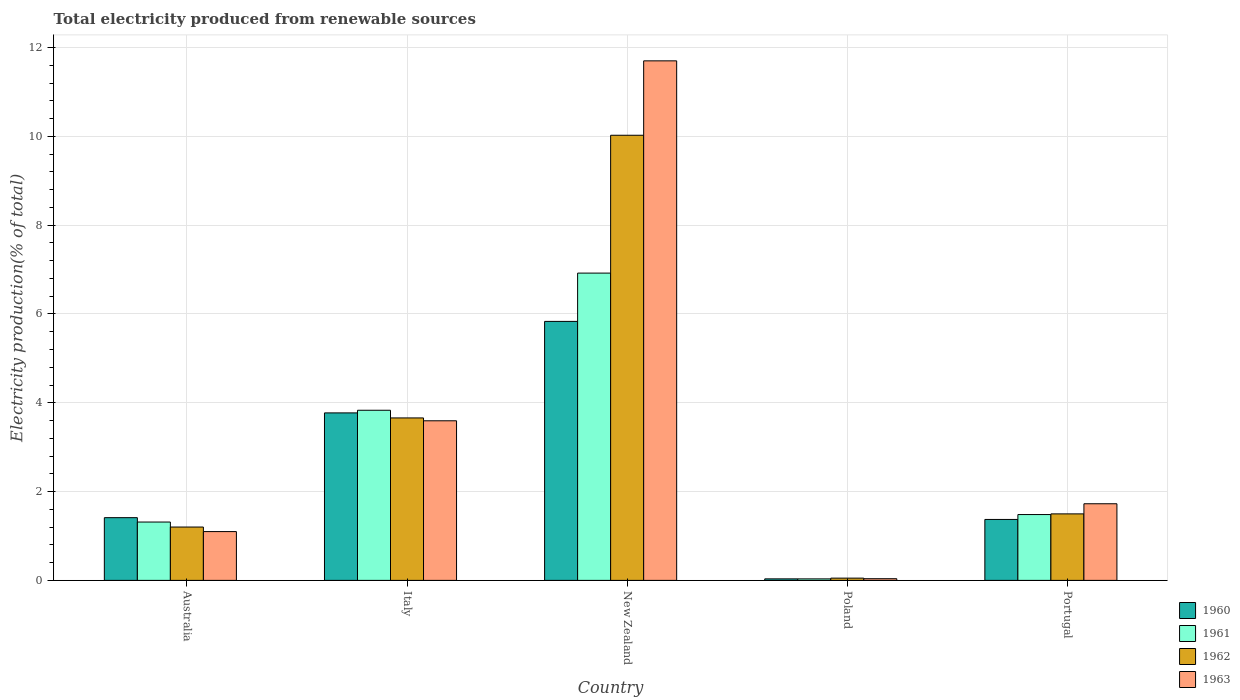Are the number of bars per tick equal to the number of legend labels?
Your answer should be very brief. Yes. Are the number of bars on each tick of the X-axis equal?
Your response must be concise. Yes. What is the label of the 1st group of bars from the left?
Ensure brevity in your answer.  Australia. In how many cases, is the number of bars for a given country not equal to the number of legend labels?
Make the answer very short. 0. What is the total electricity produced in 1962 in Australia?
Offer a terse response. 1.2. Across all countries, what is the maximum total electricity produced in 1962?
Keep it short and to the point. 10.02. Across all countries, what is the minimum total electricity produced in 1962?
Offer a terse response. 0.05. In which country was the total electricity produced in 1962 maximum?
Offer a very short reply. New Zealand. What is the total total electricity produced in 1962 in the graph?
Your answer should be very brief. 16.43. What is the difference between the total electricity produced in 1963 in New Zealand and that in Portugal?
Offer a terse response. 9.97. What is the difference between the total electricity produced in 1962 in Italy and the total electricity produced in 1960 in Australia?
Provide a succinct answer. 2.25. What is the average total electricity produced in 1962 per country?
Offer a terse response. 3.29. What is the difference between the total electricity produced of/in 1962 and total electricity produced of/in 1961 in Australia?
Provide a short and direct response. -0.11. What is the ratio of the total electricity produced in 1962 in Australia to that in Italy?
Provide a short and direct response. 0.33. Is the total electricity produced in 1962 in Australia less than that in Italy?
Offer a very short reply. Yes. What is the difference between the highest and the second highest total electricity produced in 1963?
Keep it short and to the point. 1.87. What is the difference between the highest and the lowest total electricity produced in 1963?
Your answer should be compact. 11.66. Is the sum of the total electricity produced in 1960 in Italy and New Zealand greater than the maximum total electricity produced in 1962 across all countries?
Provide a short and direct response. No. Is it the case that in every country, the sum of the total electricity produced in 1963 and total electricity produced in 1960 is greater than the sum of total electricity produced in 1961 and total electricity produced in 1962?
Make the answer very short. No. What does the 3rd bar from the left in Italy represents?
Offer a very short reply. 1962. Is it the case that in every country, the sum of the total electricity produced in 1960 and total electricity produced in 1961 is greater than the total electricity produced in 1963?
Keep it short and to the point. Yes. Are all the bars in the graph horizontal?
Offer a terse response. No. How many countries are there in the graph?
Provide a succinct answer. 5. What is the difference between two consecutive major ticks on the Y-axis?
Make the answer very short. 2. Are the values on the major ticks of Y-axis written in scientific E-notation?
Your response must be concise. No. Does the graph contain any zero values?
Offer a very short reply. No. Does the graph contain grids?
Your response must be concise. Yes. What is the title of the graph?
Ensure brevity in your answer.  Total electricity produced from renewable sources. Does "1991" appear as one of the legend labels in the graph?
Give a very brief answer. No. What is the label or title of the Y-axis?
Provide a succinct answer. Electricity production(% of total). What is the Electricity production(% of total) of 1960 in Australia?
Your response must be concise. 1.41. What is the Electricity production(% of total) in 1961 in Australia?
Make the answer very short. 1.31. What is the Electricity production(% of total) of 1962 in Australia?
Keep it short and to the point. 1.2. What is the Electricity production(% of total) of 1963 in Australia?
Provide a succinct answer. 1.1. What is the Electricity production(% of total) in 1960 in Italy?
Provide a short and direct response. 3.77. What is the Electricity production(% of total) of 1961 in Italy?
Ensure brevity in your answer.  3.83. What is the Electricity production(% of total) in 1962 in Italy?
Your response must be concise. 3.66. What is the Electricity production(% of total) of 1963 in Italy?
Provide a short and direct response. 3.59. What is the Electricity production(% of total) of 1960 in New Zealand?
Give a very brief answer. 5.83. What is the Electricity production(% of total) in 1961 in New Zealand?
Give a very brief answer. 6.92. What is the Electricity production(% of total) of 1962 in New Zealand?
Keep it short and to the point. 10.02. What is the Electricity production(% of total) of 1963 in New Zealand?
Provide a succinct answer. 11.7. What is the Electricity production(% of total) in 1960 in Poland?
Offer a terse response. 0.03. What is the Electricity production(% of total) in 1961 in Poland?
Ensure brevity in your answer.  0.03. What is the Electricity production(% of total) of 1962 in Poland?
Give a very brief answer. 0.05. What is the Electricity production(% of total) of 1963 in Poland?
Offer a very short reply. 0.04. What is the Electricity production(% of total) of 1960 in Portugal?
Give a very brief answer. 1.37. What is the Electricity production(% of total) in 1961 in Portugal?
Your response must be concise. 1.48. What is the Electricity production(% of total) of 1962 in Portugal?
Your answer should be compact. 1.5. What is the Electricity production(% of total) of 1963 in Portugal?
Your answer should be very brief. 1.73. Across all countries, what is the maximum Electricity production(% of total) in 1960?
Offer a terse response. 5.83. Across all countries, what is the maximum Electricity production(% of total) in 1961?
Ensure brevity in your answer.  6.92. Across all countries, what is the maximum Electricity production(% of total) of 1962?
Your answer should be compact. 10.02. Across all countries, what is the maximum Electricity production(% of total) of 1963?
Provide a succinct answer. 11.7. Across all countries, what is the minimum Electricity production(% of total) in 1960?
Give a very brief answer. 0.03. Across all countries, what is the minimum Electricity production(% of total) in 1961?
Offer a terse response. 0.03. Across all countries, what is the minimum Electricity production(% of total) in 1962?
Ensure brevity in your answer.  0.05. Across all countries, what is the minimum Electricity production(% of total) in 1963?
Give a very brief answer. 0.04. What is the total Electricity production(% of total) of 1960 in the graph?
Provide a succinct answer. 12.42. What is the total Electricity production(% of total) in 1961 in the graph?
Provide a short and direct response. 13.58. What is the total Electricity production(% of total) in 1962 in the graph?
Give a very brief answer. 16.43. What is the total Electricity production(% of total) in 1963 in the graph?
Provide a succinct answer. 18.16. What is the difference between the Electricity production(% of total) in 1960 in Australia and that in Italy?
Your answer should be very brief. -2.36. What is the difference between the Electricity production(% of total) in 1961 in Australia and that in Italy?
Offer a very short reply. -2.52. What is the difference between the Electricity production(% of total) in 1962 in Australia and that in Italy?
Your answer should be compact. -2.46. What is the difference between the Electricity production(% of total) in 1963 in Australia and that in Italy?
Provide a short and direct response. -2.5. What is the difference between the Electricity production(% of total) of 1960 in Australia and that in New Zealand?
Offer a very short reply. -4.42. What is the difference between the Electricity production(% of total) of 1961 in Australia and that in New Zealand?
Your answer should be compact. -5.61. What is the difference between the Electricity production(% of total) of 1962 in Australia and that in New Zealand?
Keep it short and to the point. -8.82. What is the difference between the Electricity production(% of total) of 1963 in Australia and that in New Zealand?
Ensure brevity in your answer.  -10.6. What is the difference between the Electricity production(% of total) of 1960 in Australia and that in Poland?
Provide a succinct answer. 1.38. What is the difference between the Electricity production(% of total) in 1961 in Australia and that in Poland?
Your answer should be compact. 1.28. What is the difference between the Electricity production(% of total) of 1962 in Australia and that in Poland?
Ensure brevity in your answer.  1.15. What is the difference between the Electricity production(% of total) of 1963 in Australia and that in Poland?
Offer a very short reply. 1.06. What is the difference between the Electricity production(% of total) of 1960 in Australia and that in Portugal?
Keep it short and to the point. 0.04. What is the difference between the Electricity production(% of total) in 1961 in Australia and that in Portugal?
Offer a very short reply. -0.17. What is the difference between the Electricity production(% of total) in 1962 in Australia and that in Portugal?
Offer a terse response. -0.3. What is the difference between the Electricity production(% of total) of 1963 in Australia and that in Portugal?
Offer a very short reply. -0.63. What is the difference between the Electricity production(% of total) of 1960 in Italy and that in New Zealand?
Make the answer very short. -2.06. What is the difference between the Electricity production(% of total) in 1961 in Italy and that in New Zealand?
Give a very brief answer. -3.09. What is the difference between the Electricity production(% of total) of 1962 in Italy and that in New Zealand?
Provide a short and direct response. -6.37. What is the difference between the Electricity production(% of total) in 1963 in Italy and that in New Zealand?
Provide a succinct answer. -8.11. What is the difference between the Electricity production(% of total) of 1960 in Italy and that in Poland?
Offer a terse response. 3.74. What is the difference between the Electricity production(% of total) of 1961 in Italy and that in Poland?
Your answer should be compact. 3.8. What is the difference between the Electricity production(% of total) of 1962 in Italy and that in Poland?
Provide a succinct answer. 3.61. What is the difference between the Electricity production(% of total) of 1963 in Italy and that in Poland?
Provide a short and direct response. 3.56. What is the difference between the Electricity production(% of total) of 1960 in Italy and that in Portugal?
Make the answer very short. 2.4. What is the difference between the Electricity production(% of total) of 1961 in Italy and that in Portugal?
Your response must be concise. 2.35. What is the difference between the Electricity production(% of total) of 1962 in Italy and that in Portugal?
Provide a short and direct response. 2.16. What is the difference between the Electricity production(% of total) of 1963 in Italy and that in Portugal?
Offer a very short reply. 1.87. What is the difference between the Electricity production(% of total) in 1960 in New Zealand and that in Poland?
Keep it short and to the point. 5.8. What is the difference between the Electricity production(% of total) in 1961 in New Zealand and that in Poland?
Make the answer very short. 6.89. What is the difference between the Electricity production(% of total) in 1962 in New Zealand and that in Poland?
Ensure brevity in your answer.  9.97. What is the difference between the Electricity production(% of total) of 1963 in New Zealand and that in Poland?
Your response must be concise. 11.66. What is the difference between the Electricity production(% of total) in 1960 in New Zealand and that in Portugal?
Provide a short and direct response. 4.46. What is the difference between the Electricity production(% of total) in 1961 in New Zealand and that in Portugal?
Make the answer very short. 5.44. What is the difference between the Electricity production(% of total) of 1962 in New Zealand and that in Portugal?
Provide a short and direct response. 8.53. What is the difference between the Electricity production(% of total) of 1963 in New Zealand and that in Portugal?
Keep it short and to the point. 9.97. What is the difference between the Electricity production(% of total) in 1960 in Poland and that in Portugal?
Provide a short and direct response. -1.34. What is the difference between the Electricity production(% of total) in 1961 in Poland and that in Portugal?
Provide a short and direct response. -1.45. What is the difference between the Electricity production(% of total) of 1962 in Poland and that in Portugal?
Provide a short and direct response. -1.45. What is the difference between the Electricity production(% of total) in 1963 in Poland and that in Portugal?
Your answer should be compact. -1.69. What is the difference between the Electricity production(% of total) of 1960 in Australia and the Electricity production(% of total) of 1961 in Italy?
Provide a short and direct response. -2.42. What is the difference between the Electricity production(% of total) in 1960 in Australia and the Electricity production(% of total) in 1962 in Italy?
Offer a very short reply. -2.25. What is the difference between the Electricity production(% of total) in 1960 in Australia and the Electricity production(% of total) in 1963 in Italy?
Make the answer very short. -2.18. What is the difference between the Electricity production(% of total) in 1961 in Australia and the Electricity production(% of total) in 1962 in Italy?
Keep it short and to the point. -2.34. What is the difference between the Electricity production(% of total) of 1961 in Australia and the Electricity production(% of total) of 1963 in Italy?
Give a very brief answer. -2.28. What is the difference between the Electricity production(% of total) in 1962 in Australia and the Electricity production(% of total) in 1963 in Italy?
Offer a terse response. -2.39. What is the difference between the Electricity production(% of total) of 1960 in Australia and the Electricity production(% of total) of 1961 in New Zealand?
Make the answer very short. -5.51. What is the difference between the Electricity production(% of total) in 1960 in Australia and the Electricity production(% of total) in 1962 in New Zealand?
Provide a short and direct response. -8.61. What is the difference between the Electricity production(% of total) of 1960 in Australia and the Electricity production(% of total) of 1963 in New Zealand?
Provide a short and direct response. -10.29. What is the difference between the Electricity production(% of total) of 1961 in Australia and the Electricity production(% of total) of 1962 in New Zealand?
Keep it short and to the point. -8.71. What is the difference between the Electricity production(% of total) of 1961 in Australia and the Electricity production(% of total) of 1963 in New Zealand?
Offer a very short reply. -10.39. What is the difference between the Electricity production(% of total) of 1962 in Australia and the Electricity production(% of total) of 1963 in New Zealand?
Ensure brevity in your answer.  -10.5. What is the difference between the Electricity production(% of total) of 1960 in Australia and the Electricity production(% of total) of 1961 in Poland?
Your answer should be very brief. 1.38. What is the difference between the Electricity production(% of total) in 1960 in Australia and the Electricity production(% of total) in 1962 in Poland?
Your answer should be compact. 1.36. What is the difference between the Electricity production(% of total) in 1960 in Australia and the Electricity production(% of total) in 1963 in Poland?
Keep it short and to the point. 1.37. What is the difference between the Electricity production(% of total) of 1961 in Australia and the Electricity production(% of total) of 1962 in Poland?
Keep it short and to the point. 1.26. What is the difference between the Electricity production(% of total) in 1961 in Australia and the Electricity production(% of total) in 1963 in Poland?
Your answer should be very brief. 1.28. What is the difference between the Electricity production(% of total) of 1962 in Australia and the Electricity production(% of total) of 1963 in Poland?
Give a very brief answer. 1.16. What is the difference between the Electricity production(% of total) in 1960 in Australia and the Electricity production(% of total) in 1961 in Portugal?
Your response must be concise. -0.07. What is the difference between the Electricity production(% of total) in 1960 in Australia and the Electricity production(% of total) in 1962 in Portugal?
Give a very brief answer. -0.09. What is the difference between the Electricity production(% of total) in 1960 in Australia and the Electricity production(% of total) in 1963 in Portugal?
Your answer should be compact. -0.31. What is the difference between the Electricity production(% of total) of 1961 in Australia and the Electricity production(% of total) of 1962 in Portugal?
Give a very brief answer. -0.18. What is the difference between the Electricity production(% of total) of 1961 in Australia and the Electricity production(% of total) of 1963 in Portugal?
Provide a succinct answer. -0.41. What is the difference between the Electricity production(% of total) in 1962 in Australia and the Electricity production(% of total) in 1963 in Portugal?
Ensure brevity in your answer.  -0.52. What is the difference between the Electricity production(% of total) of 1960 in Italy and the Electricity production(% of total) of 1961 in New Zealand?
Your response must be concise. -3.15. What is the difference between the Electricity production(% of total) of 1960 in Italy and the Electricity production(% of total) of 1962 in New Zealand?
Provide a succinct answer. -6.25. What is the difference between the Electricity production(% of total) of 1960 in Italy and the Electricity production(% of total) of 1963 in New Zealand?
Ensure brevity in your answer.  -7.93. What is the difference between the Electricity production(% of total) of 1961 in Italy and the Electricity production(% of total) of 1962 in New Zealand?
Make the answer very short. -6.19. What is the difference between the Electricity production(% of total) in 1961 in Italy and the Electricity production(% of total) in 1963 in New Zealand?
Give a very brief answer. -7.87. What is the difference between the Electricity production(% of total) in 1962 in Italy and the Electricity production(% of total) in 1963 in New Zealand?
Give a very brief answer. -8.04. What is the difference between the Electricity production(% of total) of 1960 in Italy and the Electricity production(% of total) of 1961 in Poland?
Provide a short and direct response. 3.74. What is the difference between the Electricity production(% of total) in 1960 in Italy and the Electricity production(% of total) in 1962 in Poland?
Your answer should be compact. 3.72. What is the difference between the Electricity production(% of total) of 1960 in Italy and the Electricity production(% of total) of 1963 in Poland?
Provide a succinct answer. 3.73. What is the difference between the Electricity production(% of total) of 1961 in Italy and the Electricity production(% of total) of 1962 in Poland?
Your answer should be compact. 3.78. What is the difference between the Electricity production(% of total) in 1961 in Italy and the Electricity production(% of total) in 1963 in Poland?
Offer a terse response. 3.79. What is the difference between the Electricity production(% of total) of 1962 in Italy and the Electricity production(% of total) of 1963 in Poland?
Give a very brief answer. 3.62. What is the difference between the Electricity production(% of total) of 1960 in Italy and the Electricity production(% of total) of 1961 in Portugal?
Provide a short and direct response. 2.29. What is the difference between the Electricity production(% of total) in 1960 in Italy and the Electricity production(% of total) in 1962 in Portugal?
Offer a terse response. 2.27. What is the difference between the Electricity production(% of total) of 1960 in Italy and the Electricity production(% of total) of 1963 in Portugal?
Offer a very short reply. 2.05. What is the difference between the Electricity production(% of total) in 1961 in Italy and the Electricity production(% of total) in 1962 in Portugal?
Your answer should be very brief. 2.33. What is the difference between the Electricity production(% of total) in 1961 in Italy and the Electricity production(% of total) in 1963 in Portugal?
Provide a short and direct response. 2.11. What is the difference between the Electricity production(% of total) in 1962 in Italy and the Electricity production(% of total) in 1963 in Portugal?
Your answer should be compact. 1.93. What is the difference between the Electricity production(% of total) of 1960 in New Zealand and the Electricity production(% of total) of 1961 in Poland?
Your response must be concise. 5.8. What is the difference between the Electricity production(% of total) of 1960 in New Zealand and the Electricity production(% of total) of 1962 in Poland?
Ensure brevity in your answer.  5.78. What is the difference between the Electricity production(% of total) in 1960 in New Zealand and the Electricity production(% of total) in 1963 in Poland?
Offer a very short reply. 5.79. What is the difference between the Electricity production(% of total) of 1961 in New Zealand and the Electricity production(% of total) of 1962 in Poland?
Your response must be concise. 6.87. What is the difference between the Electricity production(% of total) of 1961 in New Zealand and the Electricity production(% of total) of 1963 in Poland?
Give a very brief answer. 6.88. What is the difference between the Electricity production(% of total) of 1962 in New Zealand and the Electricity production(% of total) of 1963 in Poland?
Give a very brief answer. 9.99. What is the difference between the Electricity production(% of total) in 1960 in New Zealand and the Electricity production(% of total) in 1961 in Portugal?
Offer a very short reply. 4.35. What is the difference between the Electricity production(% of total) of 1960 in New Zealand and the Electricity production(% of total) of 1962 in Portugal?
Make the answer very short. 4.33. What is the difference between the Electricity production(% of total) in 1960 in New Zealand and the Electricity production(% of total) in 1963 in Portugal?
Your answer should be very brief. 4.11. What is the difference between the Electricity production(% of total) in 1961 in New Zealand and the Electricity production(% of total) in 1962 in Portugal?
Your answer should be compact. 5.42. What is the difference between the Electricity production(% of total) in 1961 in New Zealand and the Electricity production(% of total) in 1963 in Portugal?
Your answer should be very brief. 5.19. What is the difference between the Electricity production(% of total) of 1962 in New Zealand and the Electricity production(% of total) of 1963 in Portugal?
Your response must be concise. 8.3. What is the difference between the Electricity production(% of total) of 1960 in Poland and the Electricity production(% of total) of 1961 in Portugal?
Provide a short and direct response. -1.45. What is the difference between the Electricity production(% of total) of 1960 in Poland and the Electricity production(% of total) of 1962 in Portugal?
Provide a succinct answer. -1.46. What is the difference between the Electricity production(% of total) of 1960 in Poland and the Electricity production(% of total) of 1963 in Portugal?
Offer a terse response. -1.69. What is the difference between the Electricity production(% of total) in 1961 in Poland and the Electricity production(% of total) in 1962 in Portugal?
Your answer should be very brief. -1.46. What is the difference between the Electricity production(% of total) in 1961 in Poland and the Electricity production(% of total) in 1963 in Portugal?
Give a very brief answer. -1.69. What is the difference between the Electricity production(% of total) in 1962 in Poland and the Electricity production(% of total) in 1963 in Portugal?
Your answer should be very brief. -1.67. What is the average Electricity production(% of total) of 1960 per country?
Your answer should be very brief. 2.48. What is the average Electricity production(% of total) of 1961 per country?
Provide a short and direct response. 2.72. What is the average Electricity production(% of total) of 1962 per country?
Offer a terse response. 3.29. What is the average Electricity production(% of total) in 1963 per country?
Provide a short and direct response. 3.63. What is the difference between the Electricity production(% of total) of 1960 and Electricity production(% of total) of 1961 in Australia?
Your answer should be compact. 0.1. What is the difference between the Electricity production(% of total) in 1960 and Electricity production(% of total) in 1962 in Australia?
Your answer should be compact. 0.21. What is the difference between the Electricity production(% of total) in 1960 and Electricity production(% of total) in 1963 in Australia?
Provide a short and direct response. 0.31. What is the difference between the Electricity production(% of total) of 1961 and Electricity production(% of total) of 1962 in Australia?
Give a very brief answer. 0.11. What is the difference between the Electricity production(% of total) of 1961 and Electricity production(% of total) of 1963 in Australia?
Your answer should be very brief. 0.21. What is the difference between the Electricity production(% of total) of 1962 and Electricity production(% of total) of 1963 in Australia?
Offer a very short reply. 0.1. What is the difference between the Electricity production(% of total) of 1960 and Electricity production(% of total) of 1961 in Italy?
Your answer should be very brief. -0.06. What is the difference between the Electricity production(% of total) in 1960 and Electricity production(% of total) in 1962 in Italy?
Give a very brief answer. 0.11. What is the difference between the Electricity production(% of total) of 1960 and Electricity production(% of total) of 1963 in Italy?
Offer a terse response. 0.18. What is the difference between the Electricity production(% of total) in 1961 and Electricity production(% of total) in 1962 in Italy?
Make the answer very short. 0.17. What is the difference between the Electricity production(% of total) of 1961 and Electricity production(% of total) of 1963 in Italy?
Give a very brief answer. 0.24. What is the difference between the Electricity production(% of total) in 1962 and Electricity production(% of total) in 1963 in Italy?
Your answer should be compact. 0.06. What is the difference between the Electricity production(% of total) of 1960 and Electricity production(% of total) of 1961 in New Zealand?
Ensure brevity in your answer.  -1.09. What is the difference between the Electricity production(% of total) in 1960 and Electricity production(% of total) in 1962 in New Zealand?
Offer a very short reply. -4.19. What is the difference between the Electricity production(% of total) of 1960 and Electricity production(% of total) of 1963 in New Zealand?
Provide a short and direct response. -5.87. What is the difference between the Electricity production(% of total) of 1961 and Electricity production(% of total) of 1962 in New Zealand?
Ensure brevity in your answer.  -3.1. What is the difference between the Electricity production(% of total) in 1961 and Electricity production(% of total) in 1963 in New Zealand?
Provide a succinct answer. -4.78. What is the difference between the Electricity production(% of total) of 1962 and Electricity production(% of total) of 1963 in New Zealand?
Offer a terse response. -1.68. What is the difference between the Electricity production(% of total) in 1960 and Electricity production(% of total) in 1961 in Poland?
Keep it short and to the point. 0. What is the difference between the Electricity production(% of total) in 1960 and Electricity production(% of total) in 1962 in Poland?
Ensure brevity in your answer.  -0.02. What is the difference between the Electricity production(% of total) of 1960 and Electricity production(% of total) of 1963 in Poland?
Keep it short and to the point. -0. What is the difference between the Electricity production(% of total) in 1961 and Electricity production(% of total) in 1962 in Poland?
Offer a terse response. -0.02. What is the difference between the Electricity production(% of total) of 1961 and Electricity production(% of total) of 1963 in Poland?
Keep it short and to the point. -0. What is the difference between the Electricity production(% of total) in 1962 and Electricity production(% of total) in 1963 in Poland?
Provide a short and direct response. 0.01. What is the difference between the Electricity production(% of total) of 1960 and Electricity production(% of total) of 1961 in Portugal?
Make the answer very short. -0.11. What is the difference between the Electricity production(% of total) in 1960 and Electricity production(% of total) in 1962 in Portugal?
Provide a succinct answer. -0.13. What is the difference between the Electricity production(% of total) of 1960 and Electricity production(% of total) of 1963 in Portugal?
Offer a very short reply. -0.35. What is the difference between the Electricity production(% of total) in 1961 and Electricity production(% of total) in 1962 in Portugal?
Provide a short and direct response. -0.02. What is the difference between the Electricity production(% of total) in 1961 and Electricity production(% of total) in 1963 in Portugal?
Make the answer very short. -0.24. What is the difference between the Electricity production(% of total) in 1962 and Electricity production(% of total) in 1963 in Portugal?
Offer a very short reply. -0.23. What is the ratio of the Electricity production(% of total) in 1960 in Australia to that in Italy?
Your answer should be very brief. 0.37. What is the ratio of the Electricity production(% of total) in 1961 in Australia to that in Italy?
Give a very brief answer. 0.34. What is the ratio of the Electricity production(% of total) in 1962 in Australia to that in Italy?
Provide a short and direct response. 0.33. What is the ratio of the Electricity production(% of total) of 1963 in Australia to that in Italy?
Your response must be concise. 0.31. What is the ratio of the Electricity production(% of total) of 1960 in Australia to that in New Zealand?
Give a very brief answer. 0.24. What is the ratio of the Electricity production(% of total) in 1961 in Australia to that in New Zealand?
Provide a succinct answer. 0.19. What is the ratio of the Electricity production(% of total) of 1962 in Australia to that in New Zealand?
Your response must be concise. 0.12. What is the ratio of the Electricity production(% of total) of 1963 in Australia to that in New Zealand?
Ensure brevity in your answer.  0.09. What is the ratio of the Electricity production(% of total) of 1960 in Australia to that in Poland?
Ensure brevity in your answer.  41.37. What is the ratio of the Electricity production(% of total) in 1961 in Australia to that in Poland?
Your response must be concise. 38.51. What is the ratio of the Electricity production(% of total) in 1962 in Australia to that in Poland?
Provide a short and direct response. 23.61. What is the ratio of the Electricity production(% of total) of 1963 in Australia to that in Poland?
Your response must be concise. 29. What is the ratio of the Electricity production(% of total) in 1960 in Australia to that in Portugal?
Your answer should be very brief. 1.03. What is the ratio of the Electricity production(% of total) in 1961 in Australia to that in Portugal?
Your response must be concise. 0.89. What is the ratio of the Electricity production(% of total) in 1962 in Australia to that in Portugal?
Offer a terse response. 0.8. What is the ratio of the Electricity production(% of total) in 1963 in Australia to that in Portugal?
Keep it short and to the point. 0.64. What is the ratio of the Electricity production(% of total) in 1960 in Italy to that in New Zealand?
Provide a short and direct response. 0.65. What is the ratio of the Electricity production(% of total) of 1961 in Italy to that in New Zealand?
Your answer should be compact. 0.55. What is the ratio of the Electricity production(% of total) of 1962 in Italy to that in New Zealand?
Provide a short and direct response. 0.36. What is the ratio of the Electricity production(% of total) in 1963 in Italy to that in New Zealand?
Ensure brevity in your answer.  0.31. What is the ratio of the Electricity production(% of total) of 1960 in Italy to that in Poland?
Give a very brief answer. 110.45. What is the ratio of the Electricity production(% of total) of 1961 in Italy to that in Poland?
Offer a very short reply. 112.3. What is the ratio of the Electricity production(% of total) in 1962 in Italy to that in Poland?
Provide a succinct answer. 71.88. What is the ratio of the Electricity production(% of total) in 1963 in Italy to that in Poland?
Give a very brief answer. 94.84. What is the ratio of the Electricity production(% of total) in 1960 in Italy to that in Portugal?
Offer a very short reply. 2.75. What is the ratio of the Electricity production(% of total) of 1961 in Italy to that in Portugal?
Make the answer very short. 2.58. What is the ratio of the Electricity production(% of total) of 1962 in Italy to that in Portugal?
Give a very brief answer. 2.44. What is the ratio of the Electricity production(% of total) in 1963 in Italy to that in Portugal?
Provide a succinct answer. 2.08. What is the ratio of the Electricity production(% of total) of 1960 in New Zealand to that in Poland?
Offer a very short reply. 170.79. What is the ratio of the Electricity production(% of total) in 1961 in New Zealand to that in Poland?
Your response must be concise. 202.83. What is the ratio of the Electricity production(% of total) of 1962 in New Zealand to that in Poland?
Your response must be concise. 196.95. What is the ratio of the Electricity production(% of total) of 1963 in New Zealand to that in Poland?
Your answer should be very brief. 308.73. What is the ratio of the Electricity production(% of total) in 1960 in New Zealand to that in Portugal?
Your answer should be compact. 4.25. What is the ratio of the Electricity production(% of total) in 1961 in New Zealand to that in Portugal?
Offer a very short reply. 4.67. What is the ratio of the Electricity production(% of total) in 1962 in New Zealand to that in Portugal?
Your answer should be very brief. 6.69. What is the ratio of the Electricity production(% of total) of 1963 in New Zealand to that in Portugal?
Provide a succinct answer. 6.78. What is the ratio of the Electricity production(% of total) of 1960 in Poland to that in Portugal?
Offer a terse response. 0.02. What is the ratio of the Electricity production(% of total) in 1961 in Poland to that in Portugal?
Your response must be concise. 0.02. What is the ratio of the Electricity production(% of total) of 1962 in Poland to that in Portugal?
Make the answer very short. 0.03. What is the ratio of the Electricity production(% of total) of 1963 in Poland to that in Portugal?
Provide a succinct answer. 0.02. What is the difference between the highest and the second highest Electricity production(% of total) in 1960?
Offer a terse response. 2.06. What is the difference between the highest and the second highest Electricity production(% of total) in 1961?
Keep it short and to the point. 3.09. What is the difference between the highest and the second highest Electricity production(% of total) of 1962?
Your answer should be very brief. 6.37. What is the difference between the highest and the second highest Electricity production(% of total) in 1963?
Give a very brief answer. 8.11. What is the difference between the highest and the lowest Electricity production(% of total) of 1960?
Provide a short and direct response. 5.8. What is the difference between the highest and the lowest Electricity production(% of total) of 1961?
Your answer should be very brief. 6.89. What is the difference between the highest and the lowest Electricity production(% of total) in 1962?
Your response must be concise. 9.97. What is the difference between the highest and the lowest Electricity production(% of total) of 1963?
Give a very brief answer. 11.66. 